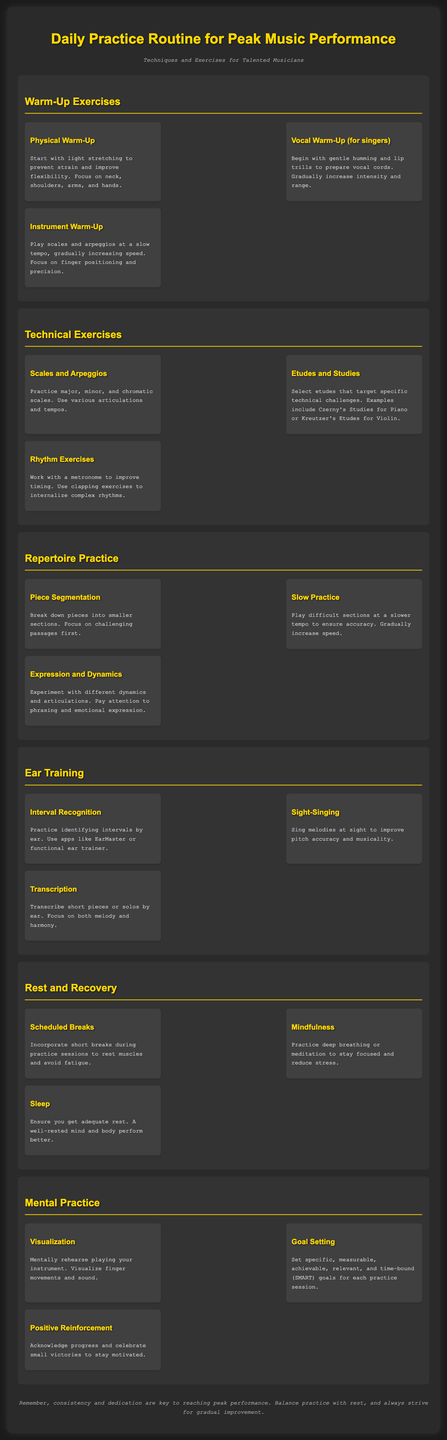What is the title of the document? The title of the document is stated at the top, which is "Daily Practice Routine for Peak Music Performance."
Answer: Daily Practice Routine for Peak Music Performance What should you start with in a Physical Warm-Up? The document suggests starting with light stretching to prevent strain and improve flexibility.
Answer: Light stretching What are the two components mentioned in the Ear Training section? The Ear Training section lists three components, two of which are Interval Recognition and Sight-Singing.
Answer: Interval Recognition, Sight-Singing What is suggested to improve timing in Rhythm Exercises? The document mentions using a metronome to improve timing.
Answer: Metronome How should difficult sections be practiced according to Slow Practice? The document recommends playing difficult sections at a slower tempo to ensure accuracy.
Answer: Slower tempo What technique involves mentally rehearsing playing your instrument? The technique described for mentally rehearsing is called Visualization.
Answer: Visualization What should be included in Scheduled Breaks during practice? The document states to incorporate short breaks during practice sessions to rest muscles and avoid fatigue.
Answer: Short breaks What is one key element for reaching peak performance? The footer emphasizes that consistency and dedication are key for reaching peak performance.
Answer: Consistency and dedication 